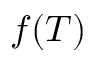<formula> <loc_0><loc_0><loc_500><loc_500>f ( T )</formula> 